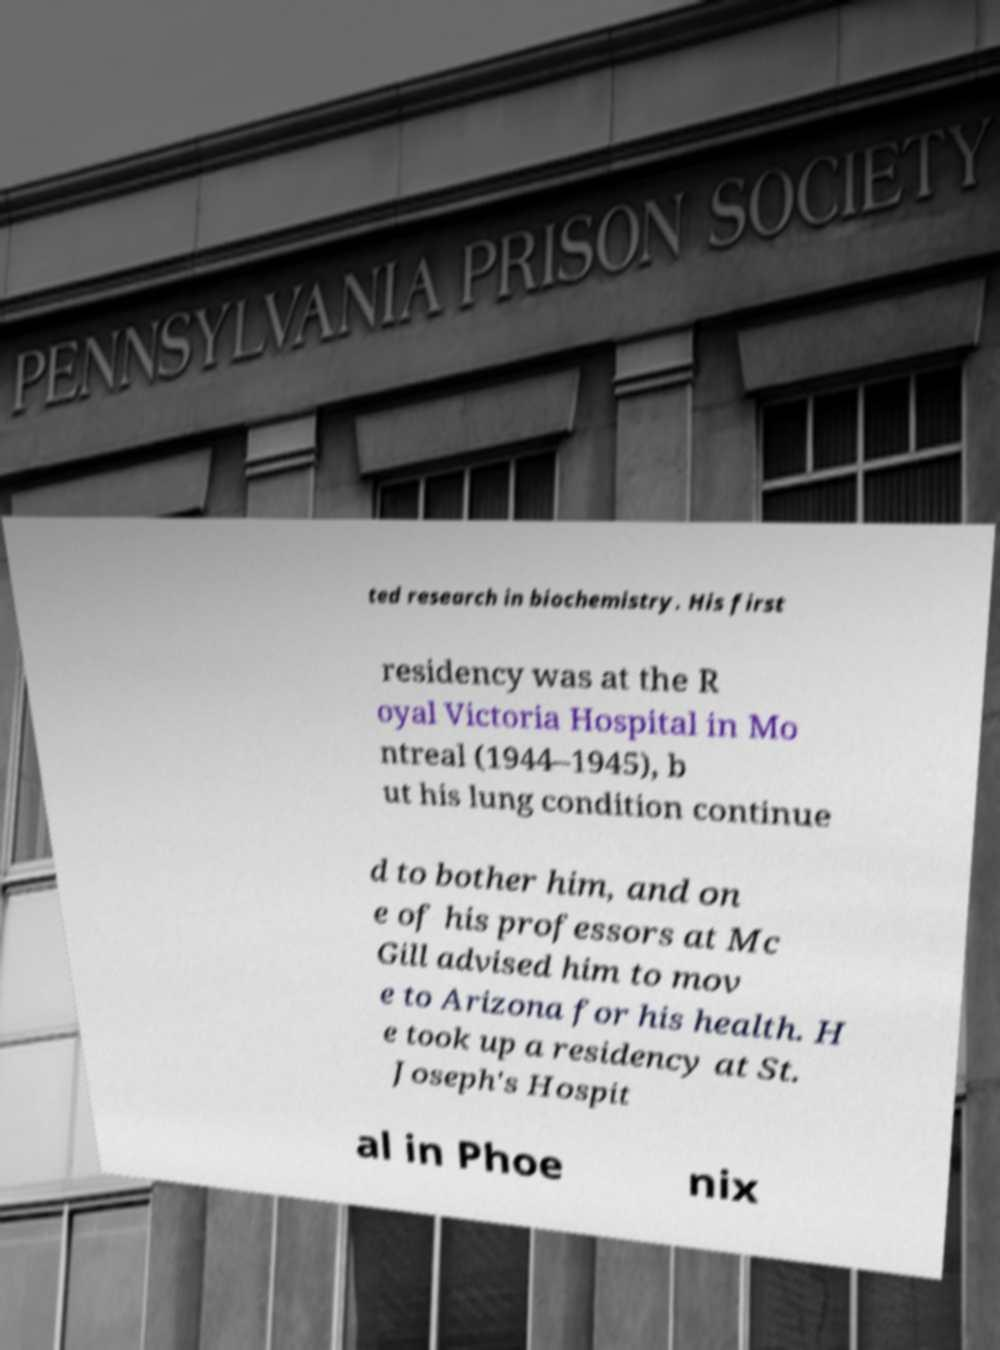I need the written content from this picture converted into text. Can you do that? ted research in biochemistry. His first residency was at the R oyal Victoria Hospital in Mo ntreal (1944–1945), b ut his lung condition continue d to bother him, and on e of his professors at Mc Gill advised him to mov e to Arizona for his health. H e took up a residency at St. Joseph's Hospit al in Phoe nix 